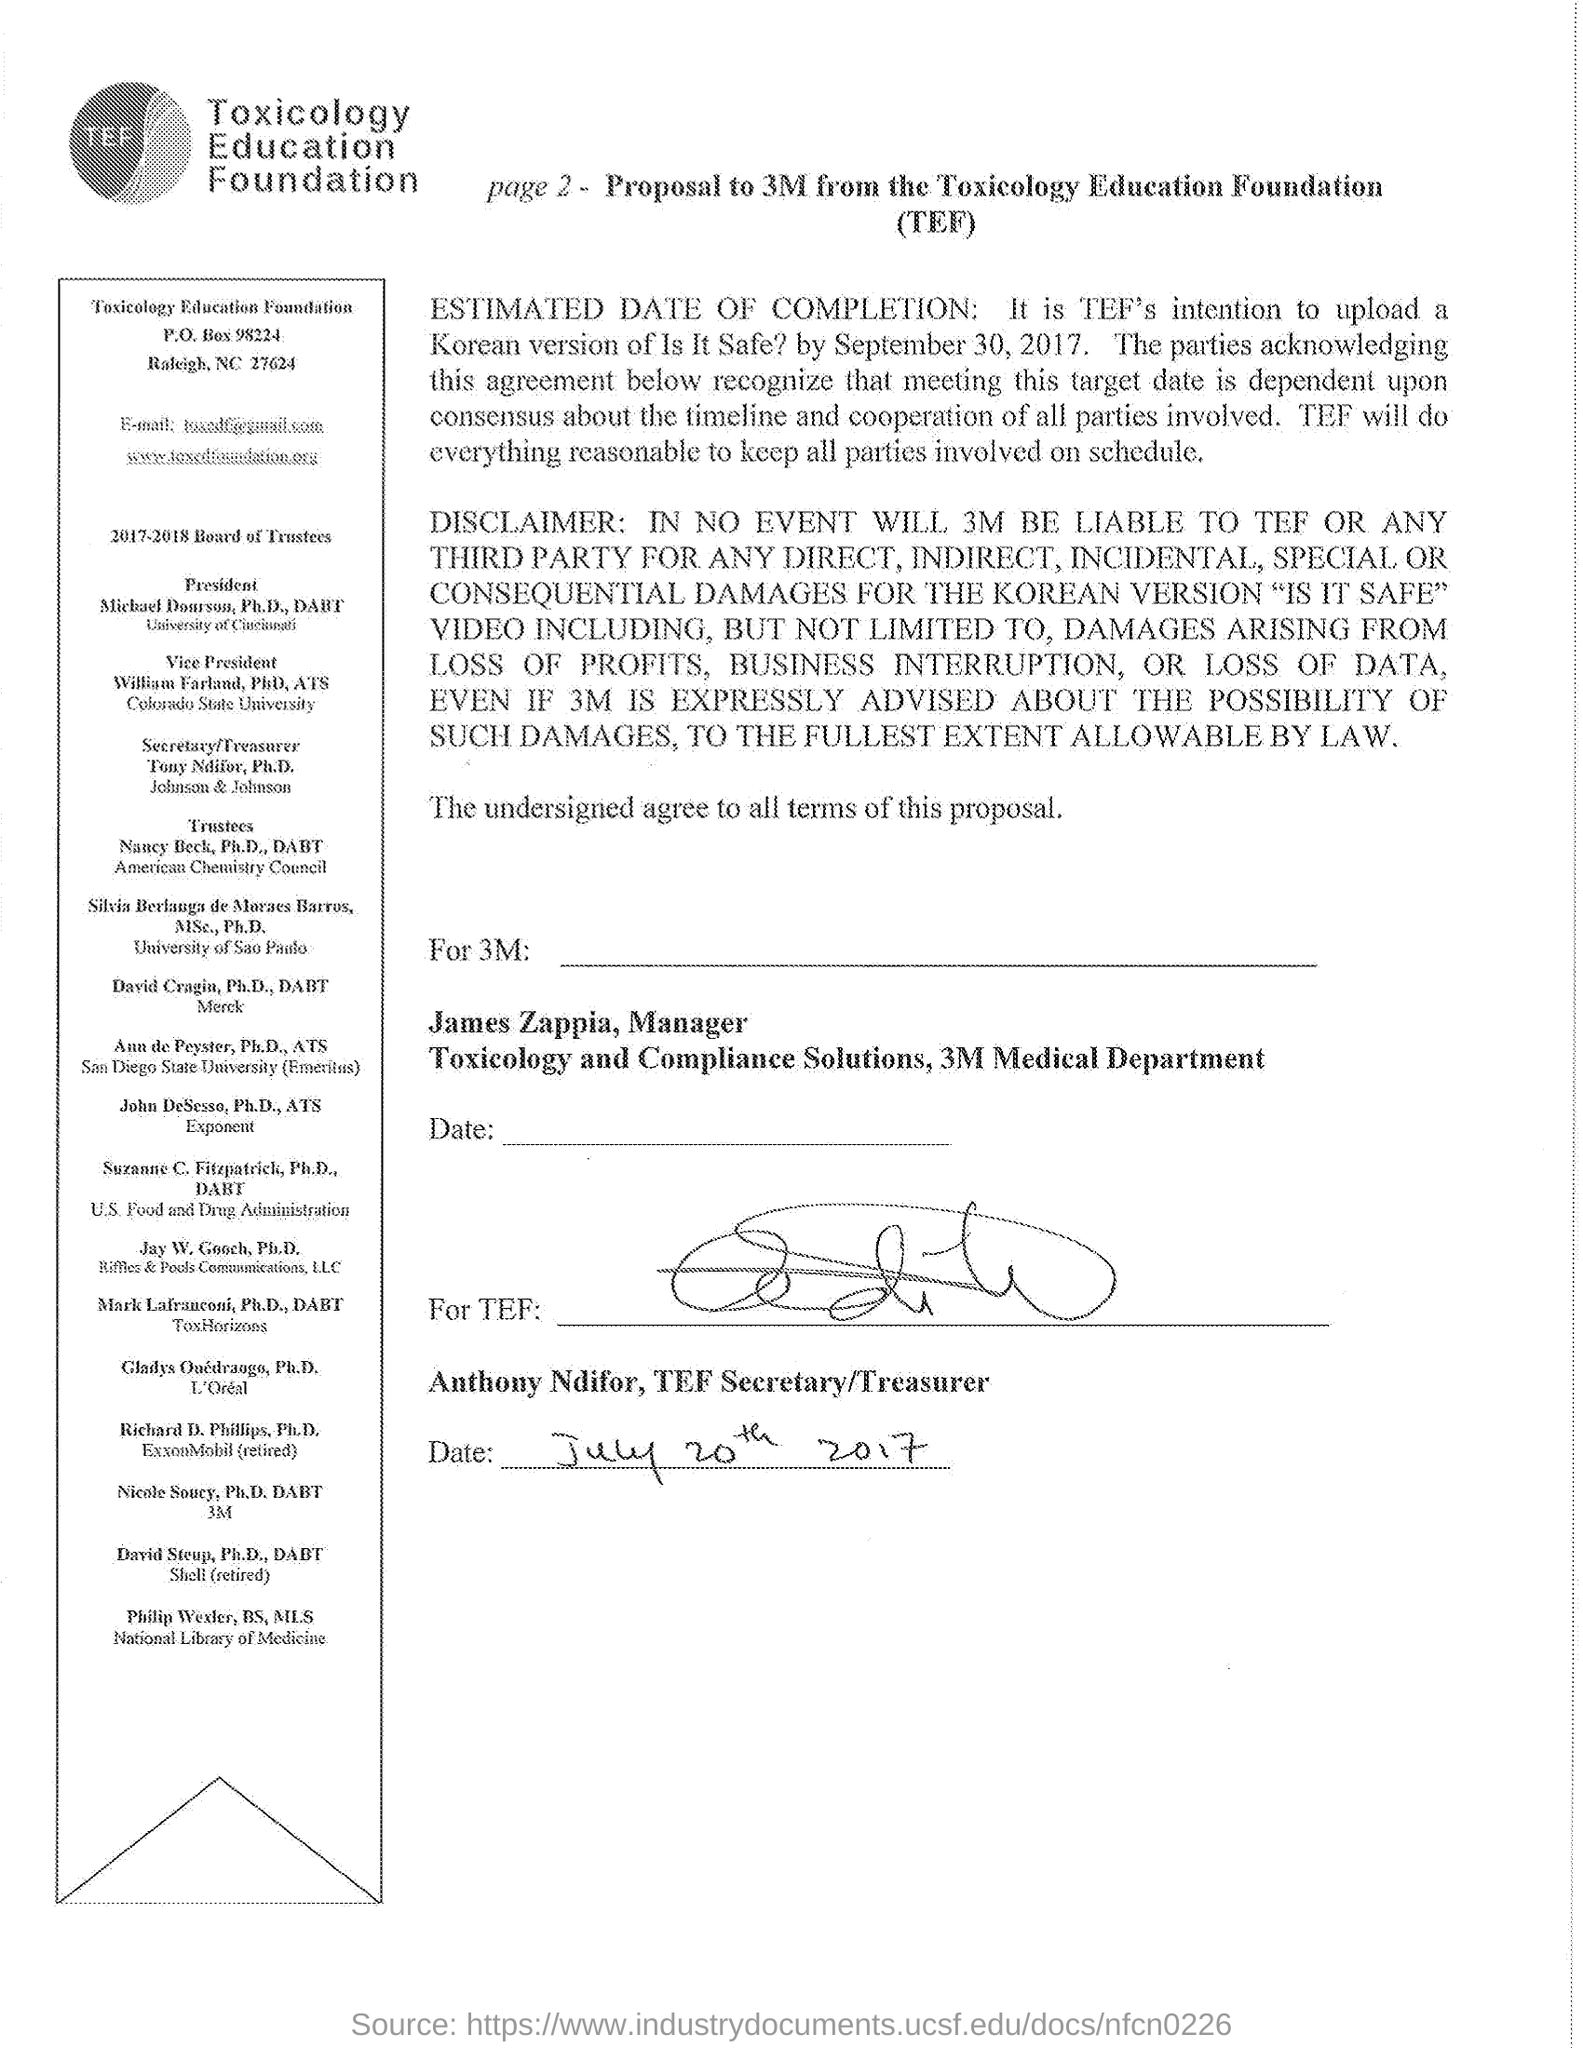What is the name of the FOUNDATION this PROPOSAL belongs to?
Offer a very short reply. TOXICOLOGY EDUCATION FOUNDATION. Who is the vice president of this FOUNDATION?
Make the answer very short. William Farland, PhD, ATS. What is the date mentioned at the bottom?
Offer a very short reply. July 20th 2017. 